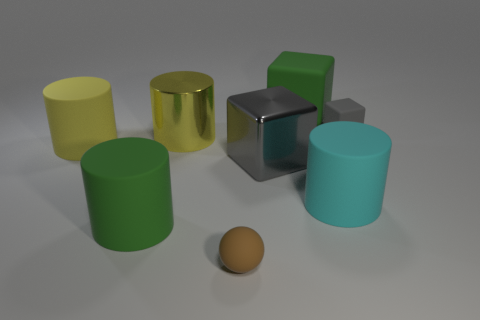Add 1 large yellow matte cylinders. How many objects exist? 9 Subtract all gray spheres. Subtract all red blocks. How many spheres are left? 1 Subtract all blocks. How many objects are left? 5 Subtract 0 gray spheres. How many objects are left? 8 Subtract all green matte blocks. Subtract all large metal things. How many objects are left? 5 Add 6 shiny cubes. How many shiny cubes are left? 7 Add 8 big gray things. How many big gray things exist? 9 